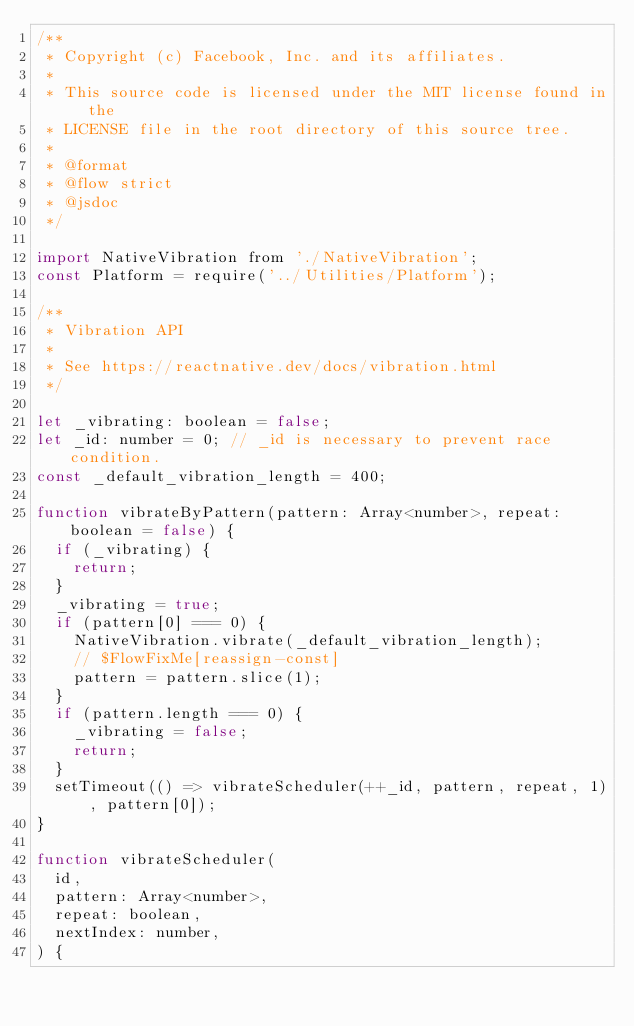Convert code to text. <code><loc_0><loc_0><loc_500><loc_500><_JavaScript_>/**
 * Copyright (c) Facebook, Inc. and its affiliates.
 *
 * This source code is licensed under the MIT license found in the
 * LICENSE file in the root directory of this source tree.
 *
 * @format
 * @flow strict
 * @jsdoc
 */

import NativeVibration from './NativeVibration';
const Platform = require('../Utilities/Platform');

/**
 * Vibration API
 *
 * See https://reactnative.dev/docs/vibration.html
 */

let _vibrating: boolean = false;
let _id: number = 0; // _id is necessary to prevent race condition.
const _default_vibration_length = 400;

function vibrateByPattern(pattern: Array<number>, repeat: boolean = false) {
  if (_vibrating) {
    return;
  }
  _vibrating = true;
  if (pattern[0] === 0) {
    NativeVibration.vibrate(_default_vibration_length);
    // $FlowFixMe[reassign-const]
    pattern = pattern.slice(1);
  }
  if (pattern.length === 0) {
    _vibrating = false;
    return;
  }
  setTimeout(() => vibrateScheduler(++_id, pattern, repeat, 1), pattern[0]);
}

function vibrateScheduler(
  id,
  pattern: Array<number>,
  repeat: boolean,
  nextIndex: number,
) {</code> 